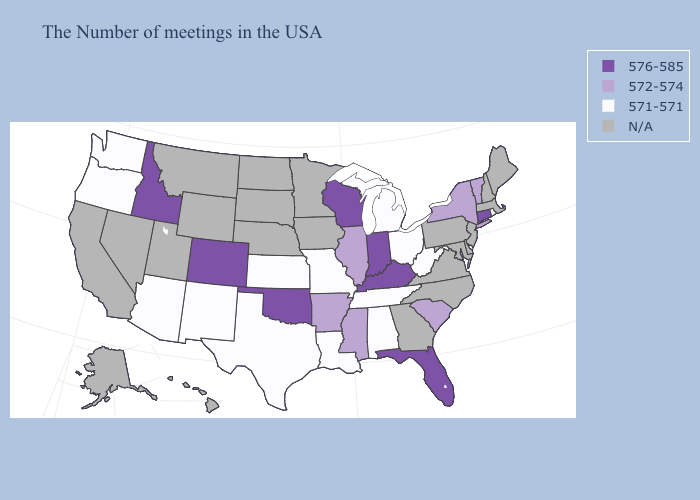What is the highest value in the USA?
Concise answer only. 576-585. Is the legend a continuous bar?
Answer briefly. No. Which states hav the highest value in the Northeast?
Short answer required. Connecticut. What is the lowest value in the South?
Be succinct. 571-571. What is the value of Arkansas?
Give a very brief answer. 572-574. Name the states that have a value in the range 572-574?
Concise answer only. Vermont, New York, South Carolina, Illinois, Mississippi, Arkansas. Name the states that have a value in the range N/A?
Be succinct. Maine, Massachusetts, New Hampshire, New Jersey, Delaware, Maryland, Pennsylvania, Virginia, North Carolina, Georgia, Minnesota, Iowa, Nebraska, South Dakota, North Dakota, Wyoming, Utah, Montana, Nevada, California, Alaska, Hawaii. Name the states that have a value in the range 571-571?
Short answer required. Rhode Island, West Virginia, Ohio, Michigan, Alabama, Tennessee, Louisiana, Missouri, Kansas, Texas, New Mexico, Arizona, Washington, Oregon. Does Oklahoma have the highest value in the South?
Short answer required. Yes. What is the value of Texas?
Be succinct. 571-571. What is the lowest value in the USA?
Answer briefly. 571-571. What is the value of Alabama?
Quick response, please. 571-571. What is the value of Rhode Island?
Quick response, please. 571-571. What is the value of Colorado?
Give a very brief answer. 576-585. Name the states that have a value in the range 571-571?
Write a very short answer. Rhode Island, West Virginia, Ohio, Michigan, Alabama, Tennessee, Louisiana, Missouri, Kansas, Texas, New Mexico, Arizona, Washington, Oregon. 